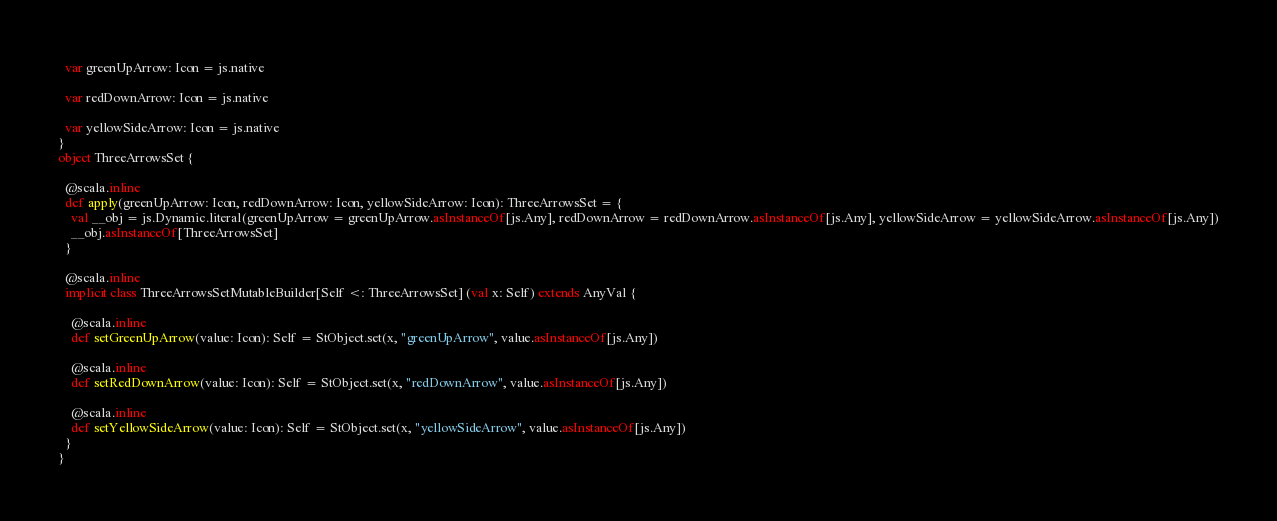Convert code to text. <code><loc_0><loc_0><loc_500><loc_500><_Scala_>  var greenUpArrow: Icon = js.native
  
  var redDownArrow: Icon = js.native
  
  var yellowSideArrow: Icon = js.native
}
object ThreeArrowsSet {
  
  @scala.inline
  def apply(greenUpArrow: Icon, redDownArrow: Icon, yellowSideArrow: Icon): ThreeArrowsSet = {
    val __obj = js.Dynamic.literal(greenUpArrow = greenUpArrow.asInstanceOf[js.Any], redDownArrow = redDownArrow.asInstanceOf[js.Any], yellowSideArrow = yellowSideArrow.asInstanceOf[js.Any])
    __obj.asInstanceOf[ThreeArrowsSet]
  }
  
  @scala.inline
  implicit class ThreeArrowsSetMutableBuilder[Self <: ThreeArrowsSet] (val x: Self) extends AnyVal {
    
    @scala.inline
    def setGreenUpArrow(value: Icon): Self = StObject.set(x, "greenUpArrow", value.asInstanceOf[js.Any])
    
    @scala.inline
    def setRedDownArrow(value: Icon): Self = StObject.set(x, "redDownArrow", value.asInstanceOf[js.Any])
    
    @scala.inline
    def setYellowSideArrow(value: Icon): Self = StObject.set(x, "yellowSideArrow", value.asInstanceOf[js.Any])
  }
}
</code> 